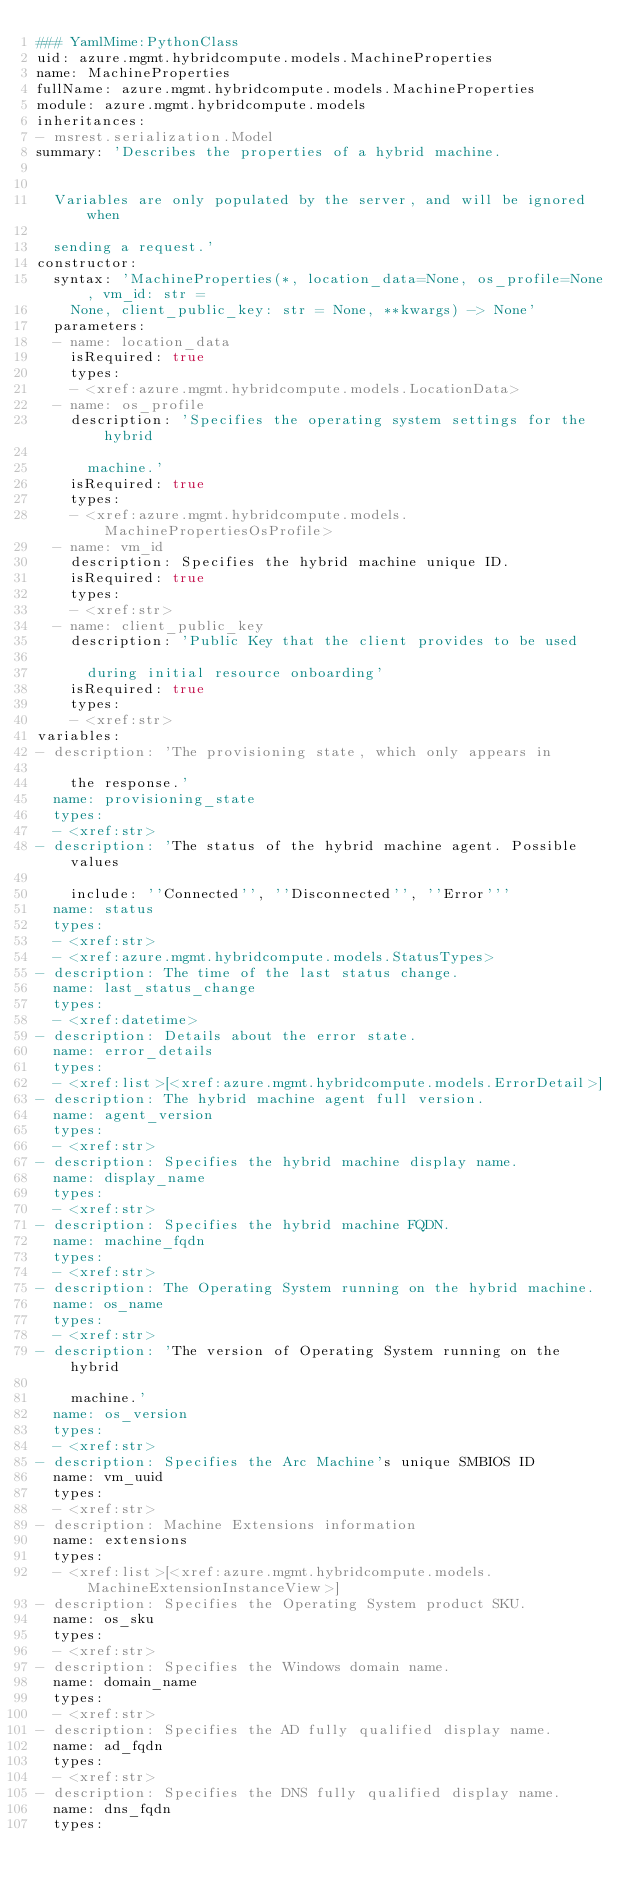<code> <loc_0><loc_0><loc_500><loc_500><_YAML_>### YamlMime:PythonClass
uid: azure.mgmt.hybridcompute.models.MachineProperties
name: MachineProperties
fullName: azure.mgmt.hybridcompute.models.MachineProperties
module: azure.mgmt.hybridcompute.models
inheritances:
- msrest.serialization.Model
summary: 'Describes the properties of a hybrid machine.


  Variables are only populated by the server, and will be ignored when

  sending a request.'
constructor:
  syntax: 'MachineProperties(*, location_data=None, os_profile=None, vm_id: str =
    None, client_public_key: str = None, **kwargs) -> None'
  parameters:
  - name: location_data
    isRequired: true
    types:
    - <xref:azure.mgmt.hybridcompute.models.LocationData>
  - name: os_profile
    description: 'Specifies the operating system settings for the hybrid

      machine.'
    isRequired: true
    types:
    - <xref:azure.mgmt.hybridcompute.models.MachinePropertiesOsProfile>
  - name: vm_id
    description: Specifies the hybrid machine unique ID.
    isRequired: true
    types:
    - <xref:str>
  - name: client_public_key
    description: 'Public Key that the client provides to be used

      during initial resource onboarding'
    isRequired: true
    types:
    - <xref:str>
variables:
- description: 'The provisioning state, which only appears in

    the response.'
  name: provisioning_state
  types:
  - <xref:str>
- description: 'The status of the hybrid machine agent. Possible values

    include: ''Connected'', ''Disconnected'', ''Error'''
  name: status
  types:
  - <xref:str>
  - <xref:azure.mgmt.hybridcompute.models.StatusTypes>
- description: The time of the last status change.
  name: last_status_change
  types:
  - <xref:datetime>
- description: Details about the error state.
  name: error_details
  types:
  - <xref:list>[<xref:azure.mgmt.hybridcompute.models.ErrorDetail>]
- description: The hybrid machine agent full version.
  name: agent_version
  types:
  - <xref:str>
- description: Specifies the hybrid machine display name.
  name: display_name
  types:
  - <xref:str>
- description: Specifies the hybrid machine FQDN.
  name: machine_fqdn
  types:
  - <xref:str>
- description: The Operating System running on the hybrid machine.
  name: os_name
  types:
  - <xref:str>
- description: 'The version of Operating System running on the hybrid

    machine.'
  name: os_version
  types:
  - <xref:str>
- description: Specifies the Arc Machine's unique SMBIOS ID
  name: vm_uuid
  types:
  - <xref:str>
- description: Machine Extensions information
  name: extensions
  types:
  - <xref:list>[<xref:azure.mgmt.hybridcompute.models.MachineExtensionInstanceView>]
- description: Specifies the Operating System product SKU.
  name: os_sku
  types:
  - <xref:str>
- description: Specifies the Windows domain name.
  name: domain_name
  types:
  - <xref:str>
- description: Specifies the AD fully qualified display name.
  name: ad_fqdn
  types:
  - <xref:str>
- description: Specifies the DNS fully qualified display name.
  name: dns_fqdn
  types:</code> 